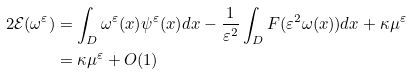Convert formula to latex. <formula><loc_0><loc_0><loc_500><loc_500>2 \mathcal { E } ( \omega ^ { \varepsilon } ) & = \int _ { D } \omega ^ { \varepsilon } ( x ) \psi ^ { \varepsilon } ( x ) d x - \frac { 1 } { \varepsilon ^ { 2 } } \int _ { D } F ( \varepsilon ^ { 2 } \omega ( x ) ) d x + \kappa \mu ^ { \varepsilon } \\ & = \kappa \mu ^ { \varepsilon } + O ( 1 )</formula> 